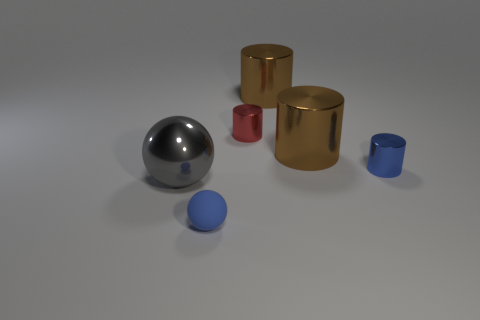How many other things are the same shape as the red metal object?
Make the answer very short. 3. Is the material of the tiny ball the same as the blue cylinder?
Your response must be concise. No. There is a thing that is both in front of the blue cylinder and on the right side of the metal ball; what is it made of?
Your answer should be compact. Rubber. There is a shiny cylinder behind the small red object; what color is it?
Your response must be concise. Brown. Are there more tiny blue rubber spheres in front of the large gray shiny sphere than spheres?
Your answer should be compact. No. How many other objects are there of the same size as the blue rubber sphere?
Offer a very short reply. 2. There is a blue rubber ball; how many spheres are behind it?
Ensure brevity in your answer.  1. Are there the same number of small blue cylinders behind the red object and blue spheres to the right of the large ball?
Offer a terse response. No. What size is the blue thing that is the same shape as the small red object?
Make the answer very short. Small. The blue object behind the gray metallic object has what shape?
Make the answer very short. Cylinder. 